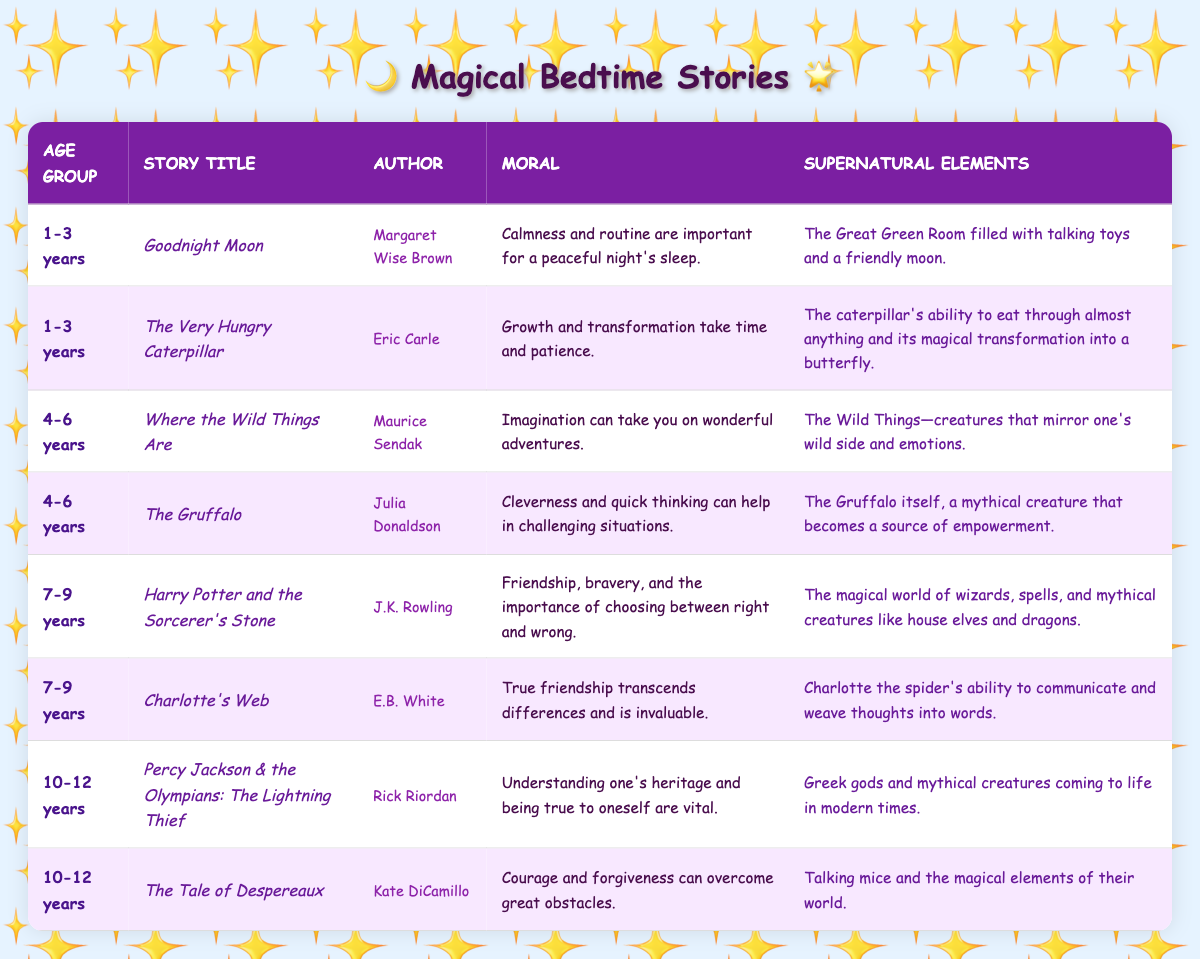What bedtime story is recommended for 4-6 years old children that emphasizes imagination? The table lists "Where the Wild Things Are" for the 4-6 years age group, highlighting the moral of imagination leading to wonderful adventures.
Answer: Where the Wild Things Are How many stories are there for the age group of 10-12 years? The table shows that there are 2 stories listed under the age group of 10-12 years, which are "Percy Jackson & the Olympians: The Lightning Thief" and "The Tale of Despereaux."
Answer: 2 Is "The Gruffalo" authored by Julia Donaldson? The table confirms that "The Gruffalo" is indeed authored by Julia Donaldson, as noted in the entry for that story.
Answer: Yes Which story for 7-9 years old discusses true friendship? The table indicates that "Charlotte's Web," listed for the 7-9 years age group, discusses true friendship and its value.
Answer: Charlotte's Web What is the moral of the story "Goodnight Moon"? According to the table, the moral of "Goodnight Moon" is about the importance of calmness and routine for a peaceful sleep, as stated in its summary.
Answer: Calmness and routine matter for peaceful sleep How many stories discuss supernatural elements for children aged 1-3 years? The table shows there are 2 stories for the age group 1-3 years: "Goodnight Moon" and "The Very Hungry Caterpillar," each featuring supernatural elements.
Answer: 2 What is the supernatural element mentioned in "Harry Potter and the Sorcerer's Stone"? The entry for "Harry Potter and the Sorcerer's Stone" in the table specifies supernatural elements, including wizards, spells, and mythical creatures like house elves and dragons.
Answer: Wizards, spells, house elves, dragons Which age group has a story that teaches about cleverness in challenging situations? The table indicates that the story "The Gruffalo," which teaches cleverness in difficult situations, is categorized under the age group of 4-6 years.
Answer: 4-6 years What moral can be derived from "Percy Jackson & the Olympians: The Lightning Thief"? The table reveals that the moral of "Percy Jackson & the Olympians: The Lightning Thief" focuses on understanding one's heritage and staying true to oneself.
Answer: Understanding heritage and being true to oneself How does the number of stories for 4-6 years compare to those for 10-12 years? The table indicates that there are 2 stories for both the 4-6 and 10-12 age groups, making the number of stories equal for these groups.
Answer: They are equal; both have 2 stories 